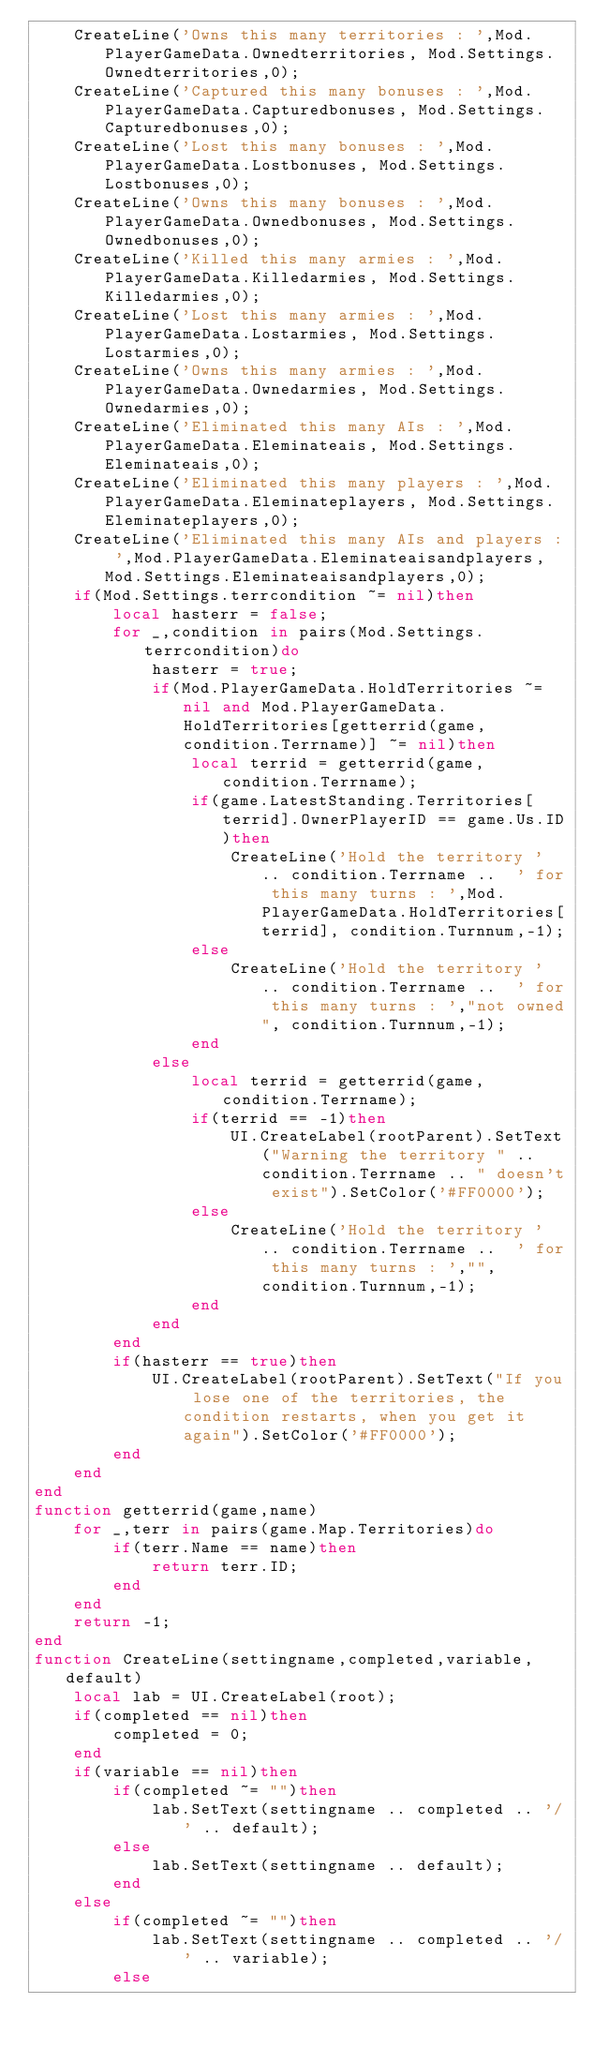<code> <loc_0><loc_0><loc_500><loc_500><_Lua_>	CreateLine('Owns this many territories : ',Mod.PlayerGameData.Ownedterritories, Mod.Settings.Ownedterritories,0);
	CreateLine('Captured this many bonuses : ',Mod.PlayerGameData.Capturedbonuses, Mod.Settings.Capturedbonuses,0);
	CreateLine('Lost this many bonuses : ',Mod.PlayerGameData.Lostbonuses, Mod.Settings.Lostbonuses,0);
	CreateLine('Owns this many bonuses : ',Mod.PlayerGameData.Ownedbonuses, Mod.Settings.Ownedbonuses,0);
	CreateLine('Killed this many armies : ',Mod.PlayerGameData.Killedarmies, Mod.Settings.Killedarmies,0);
	CreateLine('Lost this many armies : ',Mod.PlayerGameData.Lostarmies, Mod.Settings.Lostarmies,0);
	CreateLine('Owns this many armies : ',Mod.PlayerGameData.Ownedarmies, Mod.Settings.Ownedarmies,0);
	CreateLine('Eliminated this many AIs : ',Mod.PlayerGameData.Eleminateais, Mod.Settings.Eleminateais,0);
	CreateLine('Eliminated this many players : ',Mod.PlayerGameData.Eleminateplayers, Mod.Settings.Eleminateplayers,0);
	CreateLine('Eliminated this many AIs and players : ',Mod.PlayerGameData.Eleminateaisandplayers, Mod.Settings.Eleminateaisandplayers,0);
	if(Mod.Settings.terrcondition ~= nil)then
		local hasterr = false;
		for _,condition in pairs(Mod.Settings.terrcondition)do
			hasterr = true;
			if(Mod.PlayerGameData.HoldTerritories ~= nil and Mod.PlayerGameData.HoldTerritories[getterrid(game,condition.Terrname)] ~= nil)then
				local terrid = getterrid(game,condition.Terrname);
				if(game.LatestStanding.Territories[terrid].OwnerPlayerID == game.Us.ID)then
				 	CreateLine('Hold the territory ' .. condition.Terrname ..  ' for this many turns : ',Mod.PlayerGameData.HoldTerritories[terrid], condition.Turnnum,-1);
				else
					CreateLine('Hold the territory ' .. condition.Terrname ..  ' for this many turns : ',"not owned", condition.Turnnum,-1);
				end
			else
				local terrid = getterrid(game,condition.Terrname);
				if(terrid == -1)then
					UI.CreateLabel(rootParent).SetText("Warning the territory " .. condition.Terrname .. " doesn't exist").SetColor('#FF0000');
				else
					CreateLine('Hold the territory ' .. condition.Terrname ..  ' for this many turns : ',"", condition.Turnnum,-1);
				end
			end
		end
		if(hasterr == true)then
			UI.CreateLabel(rootParent).SetText("If you lose one of the territories, the condition restarts, when you get it again").SetColor('#FF0000');
		end
	end
end
function getterrid(game,name)
	for _,terr in pairs(game.Map.Territories)do
		if(terr.Name == name)then
			return terr.ID;
		end
	end
	return -1;
end
function CreateLine(settingname,completed,variable,default)
	local lab = UI.CreateLabel(root);
	if(completed == nil)then
		completed = 0;
	end
	if(variable == nil)then
		if(completed ~= "")then
			lab.SetText(settingname .. completed .. '/' .. default);
		else
			lab.SetText(settingname .. default);
		end
	else
		if(completed ~= "")then
			lab.SetText(settingname .. completed .. '/' .. variable);
		else</code> 